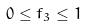<formula> <loc_0><loc_0><loc_500><loc_500>0 \leq f _ { 3 } \leq 1</formula> 